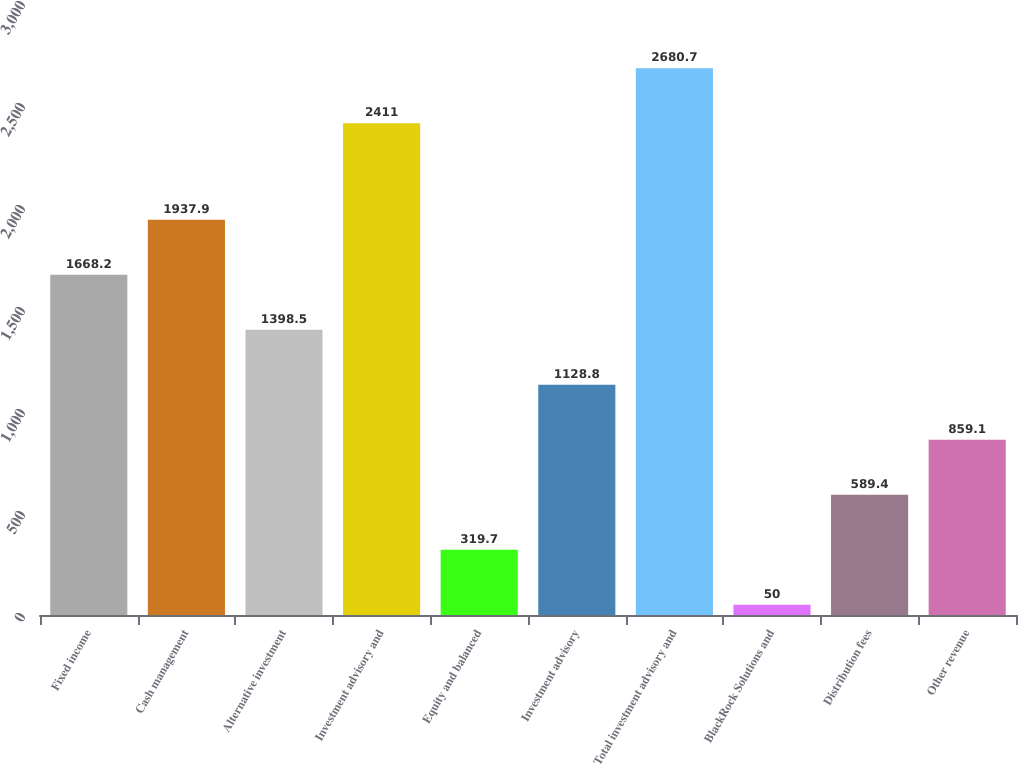Convert chart. <chart><loc_0><loc_0><loc_500><loc_500><bar_chart><fcel>Fixed income<fcel>Cash management<fcel>Alternative investment<fcel>Investment advisory and<fcel>Equity and balanced<fcel>Investment advisory<fcel>Total investment advisory and<fcel>BlackRock Solutions and<fcel>Distribution fees<fcel>Other revenue<nl><fcel>1668.2<fcel>1937.9<fcel>1398.5<fcel>2411<fcel>319.7<fcel>1128.8<fcel>2680.7<fcel>50<fcel>589.4<fcel>859.1<nl></chart> 